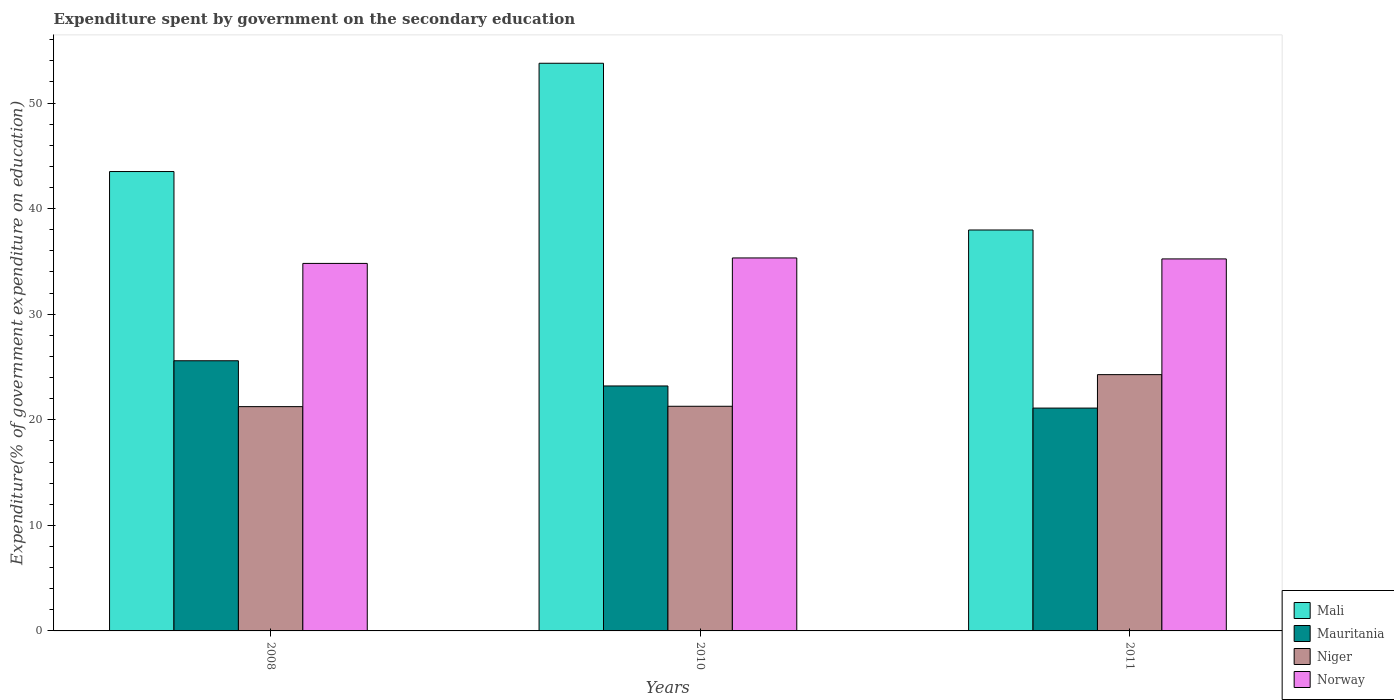How many groups of bars are there?
Make the answer very short. 3. How many bars are there on the 1st tick from the left?
Keep it short and to the point. 4. What is the label of the 2nd group of bars from the left?
Your answer should be compact. 2010. In how many cases, is the number of bars for a given year not equal to the number of legend labels?
Give a very brief answer. 0. What is the expenditure spent by government on the secondary education in Norway in 2010?
Make the answer very short. 35.33. Across all years, what is the maximum expenditure spent by government on the secondary education in Mauritania?
Offer a terse response. 25.59. Across all years, what is the minimum expenditure spent by government on the secondary education in Niger?
Your response must be concise. 21.25. In which year was the expenditure spent by government on the secondary education in Norway maximum?
Make the answer very short. 2010. In which year was the expenditure spent by government on the secondary education in Mali minimum?
Give a very brief answer. 2011. What is the total expenditure spent by government on the secondary education in Norway in the graph?
Offer a very short reply. 105.38. What is the difference between the expenditure spent by government on the secondary education in Mali in 2008 and that in 2010?
Your answer should be very brief. -10.26. What is the difference between the expenditure spent by government on the secondary education in Mauritania in 2011 and the expenditure spent by government on the secondary education in Niger in 2010?
Give a very brief answer. -0.17. What is the average expenditure spent by government on the secondary education in Mauritania per year?
Keep it short and to the point. 23.3. In the year 2011, what is the difference between the expenditure spent by government on the secondary education in Niger and expenditure spent by government on the secondary education in Norway?
Keep it short and to the point. -10.96. What is the ratio of the expenditure spent by government on the secondary education in Mauritania in 2008 to that in 2011?
Make the answer very short. 1.21. Is the expenditure spent by government on the secondary education in Mali in 2008 less than that in 2011?
Offer a very short reply. No. Is the difference between the expenditure spent by government on the secondary education in Niger in 2010 and 2011 greater than the difference between the expenditure spent by government on the secondary education in Norway in 2010 and 2011?
Your answer should be compact. No. What is the difference between the highest and the second highest expenditure spent by government on the secondary education in Niger?
Give a very brief answer. 3. What is the difference between the highest and the lowest expenditure spent by government on the secondary education in Niger?
Keep it short and to the point. 3.03. In how many years, is the expenditure spent by government on the secondary education in Mali greater than the average expenditure spent by government on the secondary education in Mali taken over all years?
Your response must be concise. 1. Is it the case that in every year, the sum of the expenditure spent by government on the secondary education in Mauritania and expenditure spent by government on the secondary education in Niger is greater than the sum of expenditure spent by government on the secondary education in Mali and expenditure spent by government on the secondary education in Norway?
Offer a terse response. No. What does the 1st bar from the left in 2010 represents?
Your answer should be very brief. Mali. Is it the case that in every year, the sum of the expenditure spent by government on the secondary education in Norway and expenditure spent by government on the secondary education in Mali is greater than the expenditure spent by government on the secondary education in Mauritania?
Make the answer very short. Yes. How many bars are there?
Make the answer very short. 12. How many years are there in the graph?
Provide a succinct answer. 3. Are the values on the major ticks of Y-axis written in scientific E-notation?
Your response must be concise. No. Does the graph contain any zero values?
Your answer should be compact. No. How are the legend labels stacked?
Your response must be concise. Vertical. What is the title of the graph?
Offer a terse response. Expenditure spent by government on the secondary education. What is the label or title of the Y-axis?
Provide a succinct answer. Expenditure(% of government expenditure on education). What is the Expenditure(% of government expenditure on education) in Mali in 2008?
Your answer should be very brief. 43.51. What is the Expenditure(% of government expenditure on education) of Mauritania in 2008?
Offer a terse response. 25.59. What is the Expenditure(% of government expenditure on education) in Niger in 2008?
Ensure brevity in your answer.  21.25. What is the Expenditure(% of government expenditure on education) in Norway in 2008?
Offer a terse response. 34.81. What is the Expenditure(% of government expenditure on education) of Mali in 2010?
Offer a terse response. 53.77. What is the Expenditure(% of government expenditure on education) of Mauritania in 2010?
Offer a terse response. 23.2. What is the Expenditure(% of government expenditure on education) in Niger in 2010?
Give a very brief answer. 21.28. What is the Expenditure(% of government expenditure on education) of Norway in 2010?
Your answer should be compact. 35.33. What is the Expenditure(% of government expenditure on education) in Mali in 2011?
Offer a very short reply. 37.98. What is the Expenditure(% of government expenditure on education) of Mauritania in 2011?
Offer a very short reply. 21.11. What is the Expenditure(% of government expenditure on education) of Niger in 2011?
Give a very brief answer. 24.28. What is the Expenditure(% of government expenditure on education) in Norway in 2011?
Provide a short and direct response. 35.24. Across all years, what is the maximum Expenditure(% of government expenditure on education) in Mali?
Offer a terse response. 53.77. Across all years, what is the maximum Expenditure(% of government expenditure on education) of Mauritania?
Your response must be concise. 25.59. Across all years, what is the maximum Expenditure(% of government expenditure on education) of Niger?
Make the answer very short. 24.28. Across all years, what is the maximum Expenditure(% of government expenditure on education) in Norway?
Your response must be concise. 35.33. Across all years, what is the minimum Expenditure(% of government expenditure on education) of Mali?
Offer a terse response. 37.98. Across all years, what is the minimum Expenditure(% of government expenditure on education) in Mauritania?
Offer a terse response. 21.11. Across all years, what is the minimum Expenditure(% of government expenditure on education) in Niger?
Provide a short and direct response. 21.25. Across all years, what is the minimum Expenditure(% of government expenditure on education) of Norway?
Your answer should be very brief. 34.81. What is the total Expenditure(% of government expenditure on education) of Mali in the graph?
Make the answer very short. 135.27. What is the total Expenditure(% of government expenditure on education) in Mauritania in the graph?
Make the answer very short. 69.9. What is the total Expenditure(% of government expenditure on education) in Niger in the graph?
Provide a short and direct response. 66.8. What is the total Expenditure(% of government expenditure on education) of Norway in the graph?
Your answer should be compact. 105.38. What is the difference between the Expenditure(% of government expenditure on education) in Mali in 2008 and that in 2010?
Your answer should be compact. -10.26. What is the difference between the Expenditure(% of government expenditure on education) of Mauritania in 2008 and that in 2010?
Keep it short and to the point. 2.39. What is the difference between the Expenditure(% of government expenditure on education) of Niger in 2008 and that in 2010?
Provide a short and direct response. -0.03. What is the difference between the Expenditure(% of government expenditure on education) in Norway in 2008 and that in 2010?
Offer a very short reply. -0.52. What is the difference between the Expenditure(% of government expenditure on education) in Mali in 2008 and that in 2011?
Make the answer very short. 5.54. What is the difference between the Expenditure(% of government expenditure on education) of Mauritania in 2008 and that in 2011?
Your answer should be compact. 4.48. What is the difference between the Expenditure(% of government expenditure on education) of Niger in 2008 and that in 2011?
Make the answer very short. -3.03. What is the difference between the Expenditure(% of government expenditure on education) of Norway in 2008 and that in 2011?
Your response must be concise. -0.43. What is the difference between the Expenditure(% of government expenditure on education) in Mali in 2010 and that in 2011?
Offer a very short reply. 15.79. What is the difference between the Expenditure(% of government expenditure on education) of Mauritania in 2010 and that in 2011?
Keep it short and to the point. 2.1. What is the difference between the Expenditure(% of government expenditure on education) in Niger in 2010 and that in 2011?
Offer a very short reply. -3. What is the difference between the Expenditure(% of government expenditure on education) of Norway in 2010 and that in 2011?
Make the answer very short. 0.09. What is the difference between the Expenditure(% of government expenditure on education) of Mali in 2008 and the Expenditure(% of government expenditure on education) of Mauritania in 2010?
Offer a very short reply. 20.31. What is the difference between the Expenditure(% of government expenditure on education) in Mali in 2008 and the Expenditure(% of government expenditure on education) in Niger in 2010?
Provide a short and direct response. 22.23. What is the difference between the Expenditure(% of government expenditure on education) of Mali in 2008 and the Expenditure(% of government expenditure on education) of Norway in 2010?
Your answer should be compact. 8.18. What is the difference between the Expenditure(% of government expenditure on education) in Mauritania in 2008 and the Expenditure(% of government expenditure on education) in Niger in 2010?
Provide a succinct answer. 4.31. What is the difference between the Expenditure(% of government expenditure on education) in Mauritania in 2008 and the Expenditure(% of government expenditure on education) in Norway in 2010?
Provide a succinct answer. -9.74. What is the difference between the Expenditure(% of government expenditure on education) of Niger in 2008 and the Expenditure(% of government expenditure on education) of Norway in 2010?
Your answer should be compact. -14.08. What is the difference between the Expenditure(% of government expenditure on education) of Mali in 2008 and the Expenditure(% of government expenditure on education) of Mauritania in 2011?
Provide a succinct answer. 22.41. What is the difference between the Expenditure(% of government expenditure on education) in Mali in 2008 and the Expenditure(% of government expenditure on education) in Niger in 2011?
Offer a terse response. 19.24. What is the difference between the Expenditure(% of government expenditure on education) of Mali in 2008 and the Expenditure(% of government expenditure on education) of Norway in 2011?
Provide a short and direct response. 8.28. What is the difference between the Expenditure(% of government expenditure on education) of Mauritania in 2008 and the Expenditure(% of government expenditure on education) of Niger in 2011?
Give a very brief answer. 1.31. What is the difference between the Expenditure(% of government expenditure on education) of Mauritania in 2008 and the Expenditure(% of government expenditure on education) of Norway in 2011?
Make the answer very short. -9.65. What is the difference between the Expenditure(% of government expenditure on education) in Niger in 2008 and the Expenditure(% of government expenditure on education) in Norway in 2011?
Make the answer very short. -13.99. What is the difference between the Expenditure(% of government expenditure on education) in Mali in 2010 and the Expenditure(% of government expenditure on education) in Mauritania in 2011?
Offer a terse response. 32.66. What is the difference between the Expenditure(% of government expenditure on education) in Mali in 2010 and the Expenditure(% of government expenditure on education) in Niger in 2011?
Your answer should be compact. 29.49. What is the difference between the Expenditure(% of government expenditure on education) in Mali in 2010 and the Expenditure(% of government expenditure on education) in Norway in 2011?
Offer a very short reply. 18.53. What is the difference between the Expenditure(% of government expenditure on education) of Mauritania in 2010 and the Expenditure(% of government expenditure on education) of Niger in 2011?
Ensure brevity in your answer.  -1.07. What is the difference between the Expenditure(% of government expenditure on education) in Mauritania in 2010 and the Expenditure(% of government expenditure on education) in Norway in 2011?
Provide a succinct answer. -12.03. What is the difference between the Expenditure(% of government expenditure on education) in Niger in 2010 and the Expenditure(% of government expenditure on education) in Norway in 2011?
Make the answer very short. -13.96. What is the average Expenditure(% of government expenditure on education) in Mali per year?
Ensure brevity in your answer.  45.09. What is the average Expenditure(% of government expenditure on education) in Mauritania per year?
Ensure brevity in your answer.  23.3. What is the average Expenditure(% of government expenditure on education) of Niger per year?
Make the answer very short. 22.27. What is the average Expenditure(% of government expenditure on education) of Norway per year?
Your answer should be compact. 35.13. In the year 2008, what is the difference between the Expenditure(% of government expenditure on education) of Mali and Expenditure(% of government expenditure on education) of Mauritania?
Make the answer very short. 17.92. In the year 2008, what is the difference between the Expenditure(% of government expenditure on education) of Mali and Expenditure(% of government expenditure on education) of Niger?
Keep it short and to the point. 22.27. In the year 2008, what is the difference between the Expenditure(% of government expenditure on education) in Mali and Expenditure(% of government expenditure on education) in Norway?
Your response must be concise. 8.7. In the year 2008, what is the difference between the Expenditure(% of government expenditure on education) of Mauritania and Expenditure(% of government expenditure on education) of Niger?
Ensure brevity in your answer.  4.34. In the year 2008, what is the difference between the Expenditure(% of government expenditure on education) of Mauritania and Expenditure(% of government expenditure on education) of Norway?
Your answer should be compact. -9.22. In the year 2008, what is the difference between the Expenditure(% of government expenditure on education) of Niger and Expenditure(% of government expenditure on education) of Norway?
Give a very brief answer. -13.57. In the year 2010, what is the difference between the Expenditure(% of government expenditure on education) in Mali and Expenditure(% of government expenditure on education) in Mauritania?
Your answer should be compact. 30.57. In the year 2010, what is the difference between the Expenditure(% of government expenditure on education) in Mali and Expenditure(% of government expenditure on education) in Niger?
Offer a very short reply. 32.49. In the year 2010, what is the difference between the Expenditure(% of government expenditure on education) of Mali and Expenditure(% of government expenditure on education) of Norway?
Give a very brief answer. 18.44. In the year 2010, what is the difference between the Expenditure(% of government expenditure on education) of Mauritania and Expenditure(% of government expenditure on education) of Niger?
Keep it short and to the point. 1.92. In the year 2010, what is the difference between the Expenditure(% of government expenditure on education) of Mauritania and Expenditure(% of government expenditure on education) of Norway?
Give a very brief answer. -12.13. In the year 2010, what is the difference between the Expenditure(% of government expenditure on education) of Niger and Expenditure(% of government expenditure on education) of Norway?
Keep it short and to the point. -14.05. In the year 2011, what is the difference between the Expenditure(% of government expenditure on education) of Mali and Expenditure(% of government expenditure on education) of Mauritania?
Provide a succinct answer. 16.87. In the year 2011, what is the difference between the Expenditure(% of government expenditure on education) in Mali and Expenditure(% of government expenditure on education) in Niger?
Ensure brevity in your answer.  13.7. In the year 2011, what is the difference between the Expenditure(% of government expenditure on education) of Mali and Expenditure(% of government expenditure on education) of Norway?
Offer a very short reply. 2.74. In the year 2011, what is the difference between the Expenditure(% of government expenditure on education) in Mauritania and Expenditure(% of government expenditure on education) in Niger?
Your answer should be compact. -3.17. In the year 2011, what is the difference between the Expenditure(% of government expenditure on education) of Mauritania and Expenditure(% of government expenditure on education) of Norway?
Ensure brevity in your answer.  -14.13. In the year 2011, what is the difference between the Expenditure(% of government expenditure on education) of Niger and Expenditure(% of government expenditure on education) of Norway?
Provide a short and direct response. -10.96. What is the ratio of the Expenditure(% of government expenditure on education) of Mali in 2008 to that in 2010?
Make the answer very short. 0.81. What is the ratio of the Expenditure(% of government expenditure on education) in Mauritania in 2008 to that in 2010?
Keep it short and to the point. 1.1. What is the ratio of the Expenditure(% of government expenditure on education) of Niger in 2008 to that in 2010?
Ensure brevity in your answer.  1. What is the ratio of the Expenditure(% of government expenditure on education) in Norway in 2008 to that in 2010?
Ensure brevity in your answer.  0.99. What is the ratio of the Expenditure(% of government expenditure on education) in Mali in 2008 to that in 2011?
Give a very brief answer. 1.15. What is the ratio of the Expenditure(% of government expenditure on education) of Mauritania in 2008 to that in 2011?
Keep it short and to the point. 1.21. What is the ratio of the Expenditure(% of government expenditure on education) in Niger in 2008 to that in 2011?
Provide a succinct answer. 0.88. What is the ratio of the Expenditure(% of government expenditure on education) in Norway in 2008 to that in 2011?
Offer a very short reply. 0.99. What is the ratio of the Expenditure(% of government expenditure on education) of Mali in 2010 to that in 2011?
Your response must be concise. 1.42. What is the ratio of the Expenditure(% of government expenditure on education) of Mauritania in 2010 to that in 2011?
Your response must be concise. 1.1. What is the ratio of the Expenditure(% of government expenditure on education) of Niger in 2010 to that in 2011?
Make the answer very short. 0.88. What is the difference between the highest and the second highest Expenditure(% of government expenditure on education) in Mali?
Provide a short and direct response. 10.26. What is the difference between the highest and the second highest Expenditure(% of government expenditure on education) in Mauritania?
Your answer should be very brief. 2.39. What is the difference between the highest and the second highest Expenditure(% of government expenditure on education) in Niger?
Provide a short and direct response. 3. What is the difference between the highest and the second highest Expenditure(% of government expenditure on education) of Norway?
Offer a very short reply. 0.09. What is the difference between the highest and the lowest Expenditure(% of government expenditure on education) in Mali?
Offer a very short reply. 15.79. What is the difference between the highest and the lowest Expenditure(% of government expenditure on education) in Mauritania?
Your answer should be compact. 4.48. What is the difference between the highest and the lowest Expenditure(% of government expenditure on education) in Niger?
Keep it short and to the point. 3.03. What is the difference between the highest and the lowest Expenditure(% of government expenditure on education) of Norway?
Offer a terse response. 0.52. 